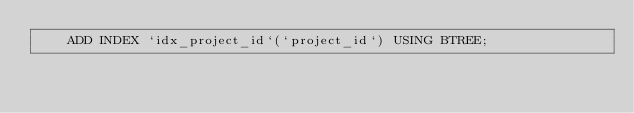<code> <loc_0><loc_0><loc_500><loc_500><_SQL_>    ADD INDEX `idx_project_id`(`project_id`) USING BTREE;
</code> 